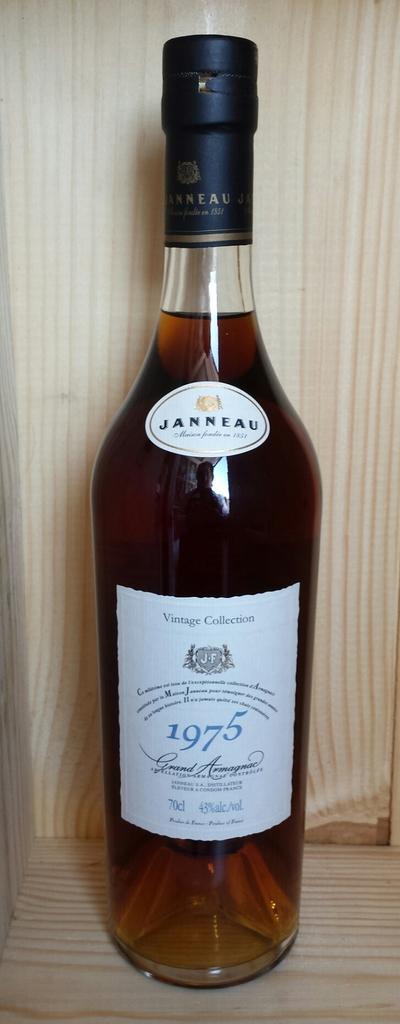What year is this bottle of wine distilled?
Your response must be concise. 1975. 